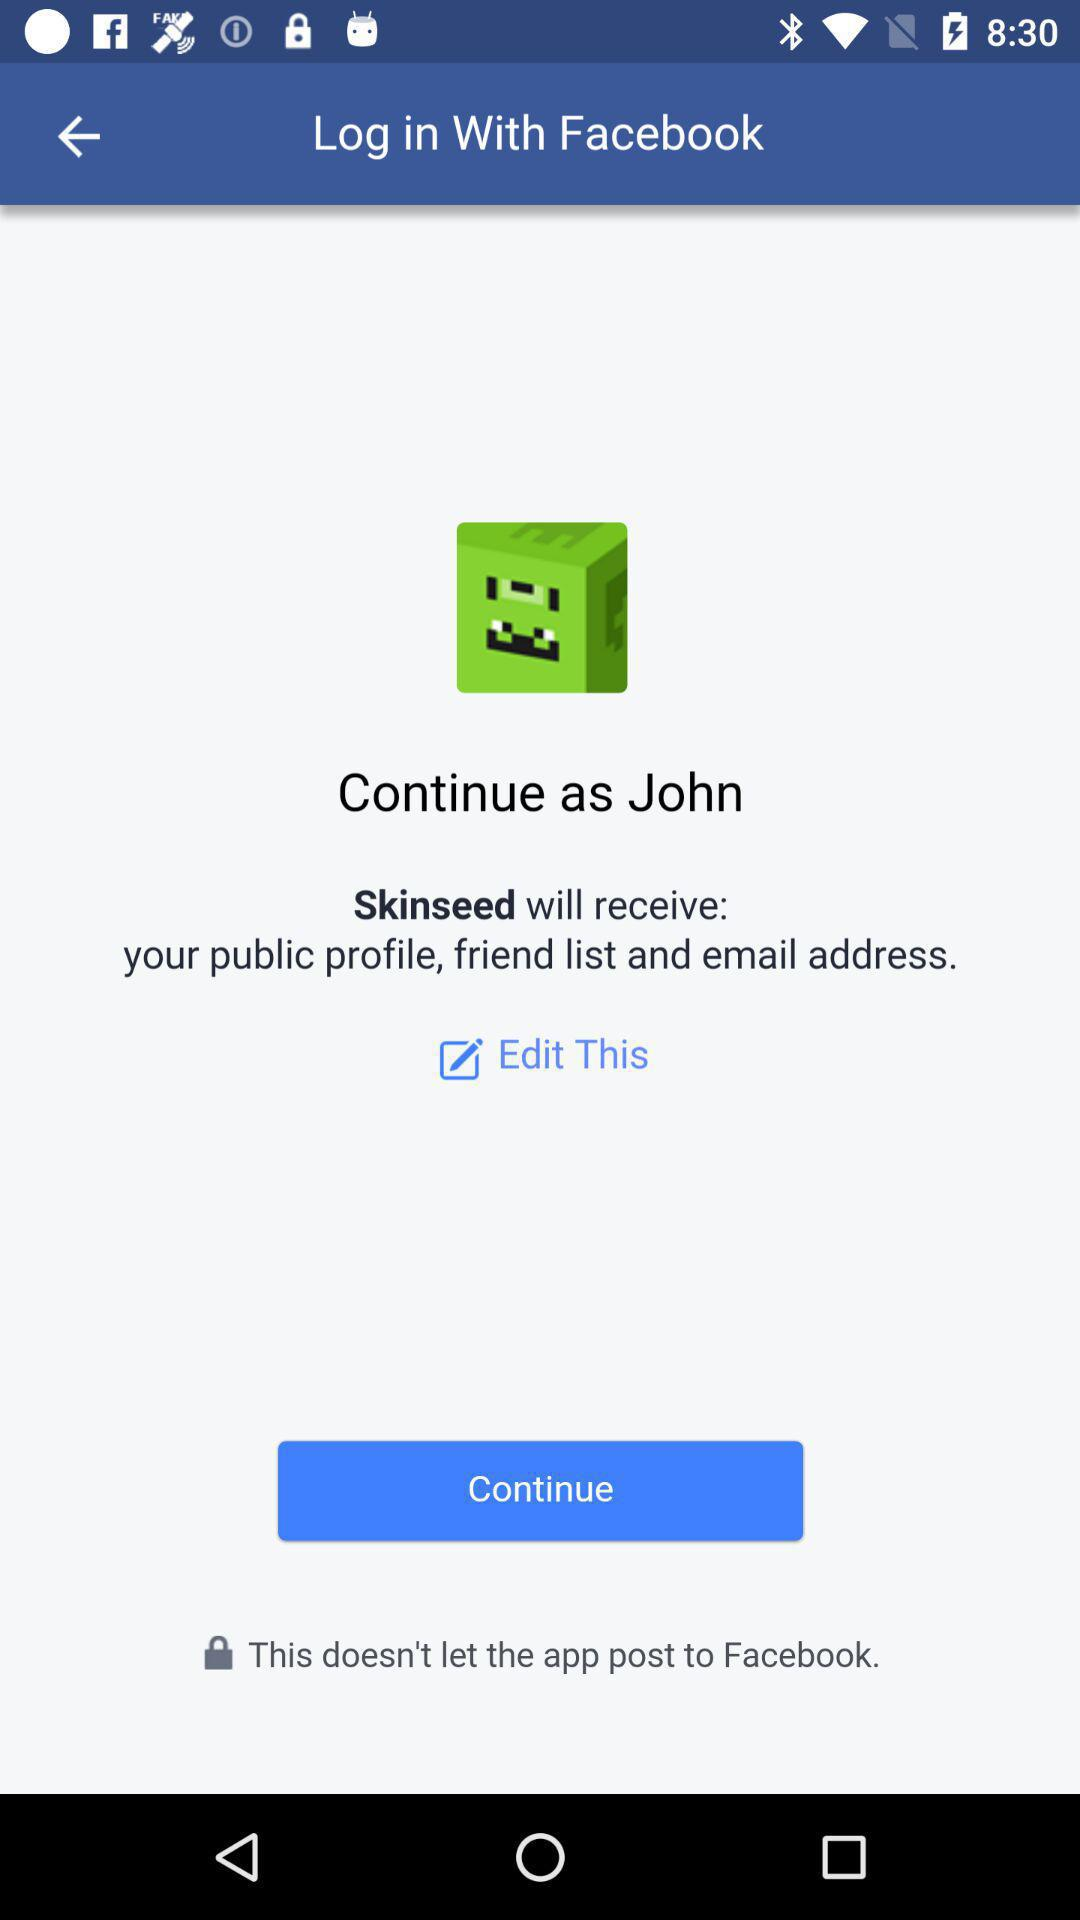Who will receive the public profile and email address? The application "Skinseed" will receive the public profile and email address. 